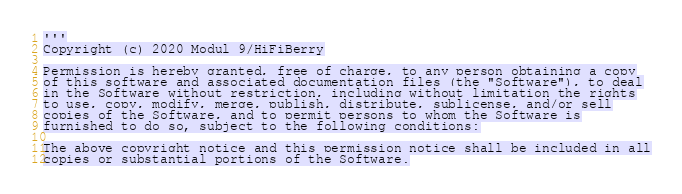Convert code to text. <code><loc_0><loc_0><loc_500><loc_500><_Python_>'''
Copyright (c) 2020 Modul 9/HiFiBerry

Permission is hereby granted, free of charge, to any person obtaining a copy
of this software and associated documentation files (the "Software"), to deal
in the Software without restriction, including without limitation the rights
to use, copy, modify, merge, publish, distribute, sublicense, and/or sell
copies of the Software, and to permit persons to whom the Software is
furnished to do so, subject to the following conditions:

The above copyright notice and this permission notice shall be included in all
copies or substantial portions of the Software.
</code> 